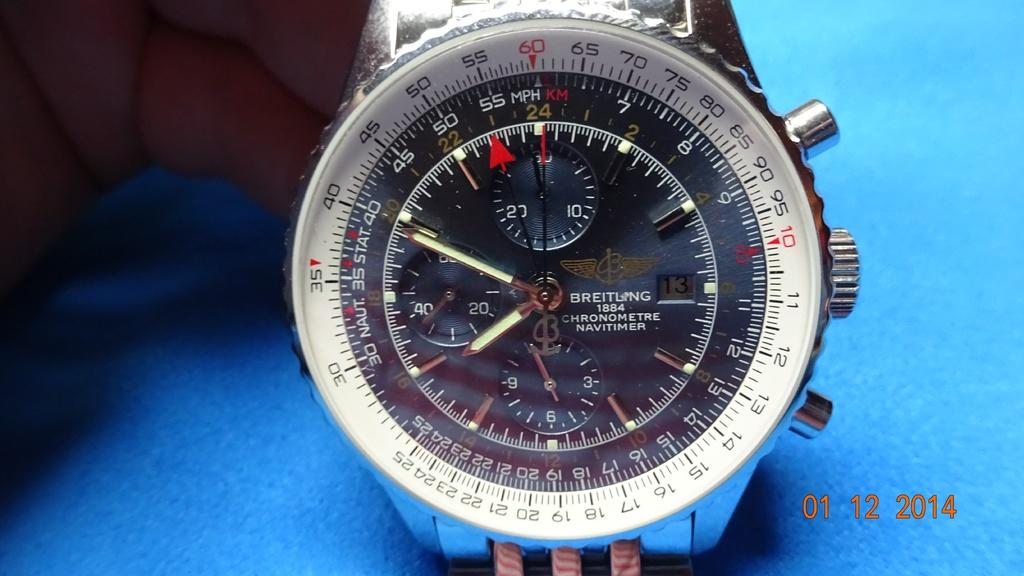<image>
Offer a succinct explanation of the picture presented. A Breitling wristwatch sits on a blue platform. 